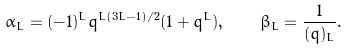Convert formula to latex. <formula><loc_0><loc_0><loc_500><loc_500>\alpha _ { L } = ( - 1 ) ^ { L } q ^ { L ( 3 L - 1 ) / 2 } ( 1 + q ^ { L } ) , \quad \beta _ { L } = \frac { 1 } { ( q ) _ { L } } .</formula> 